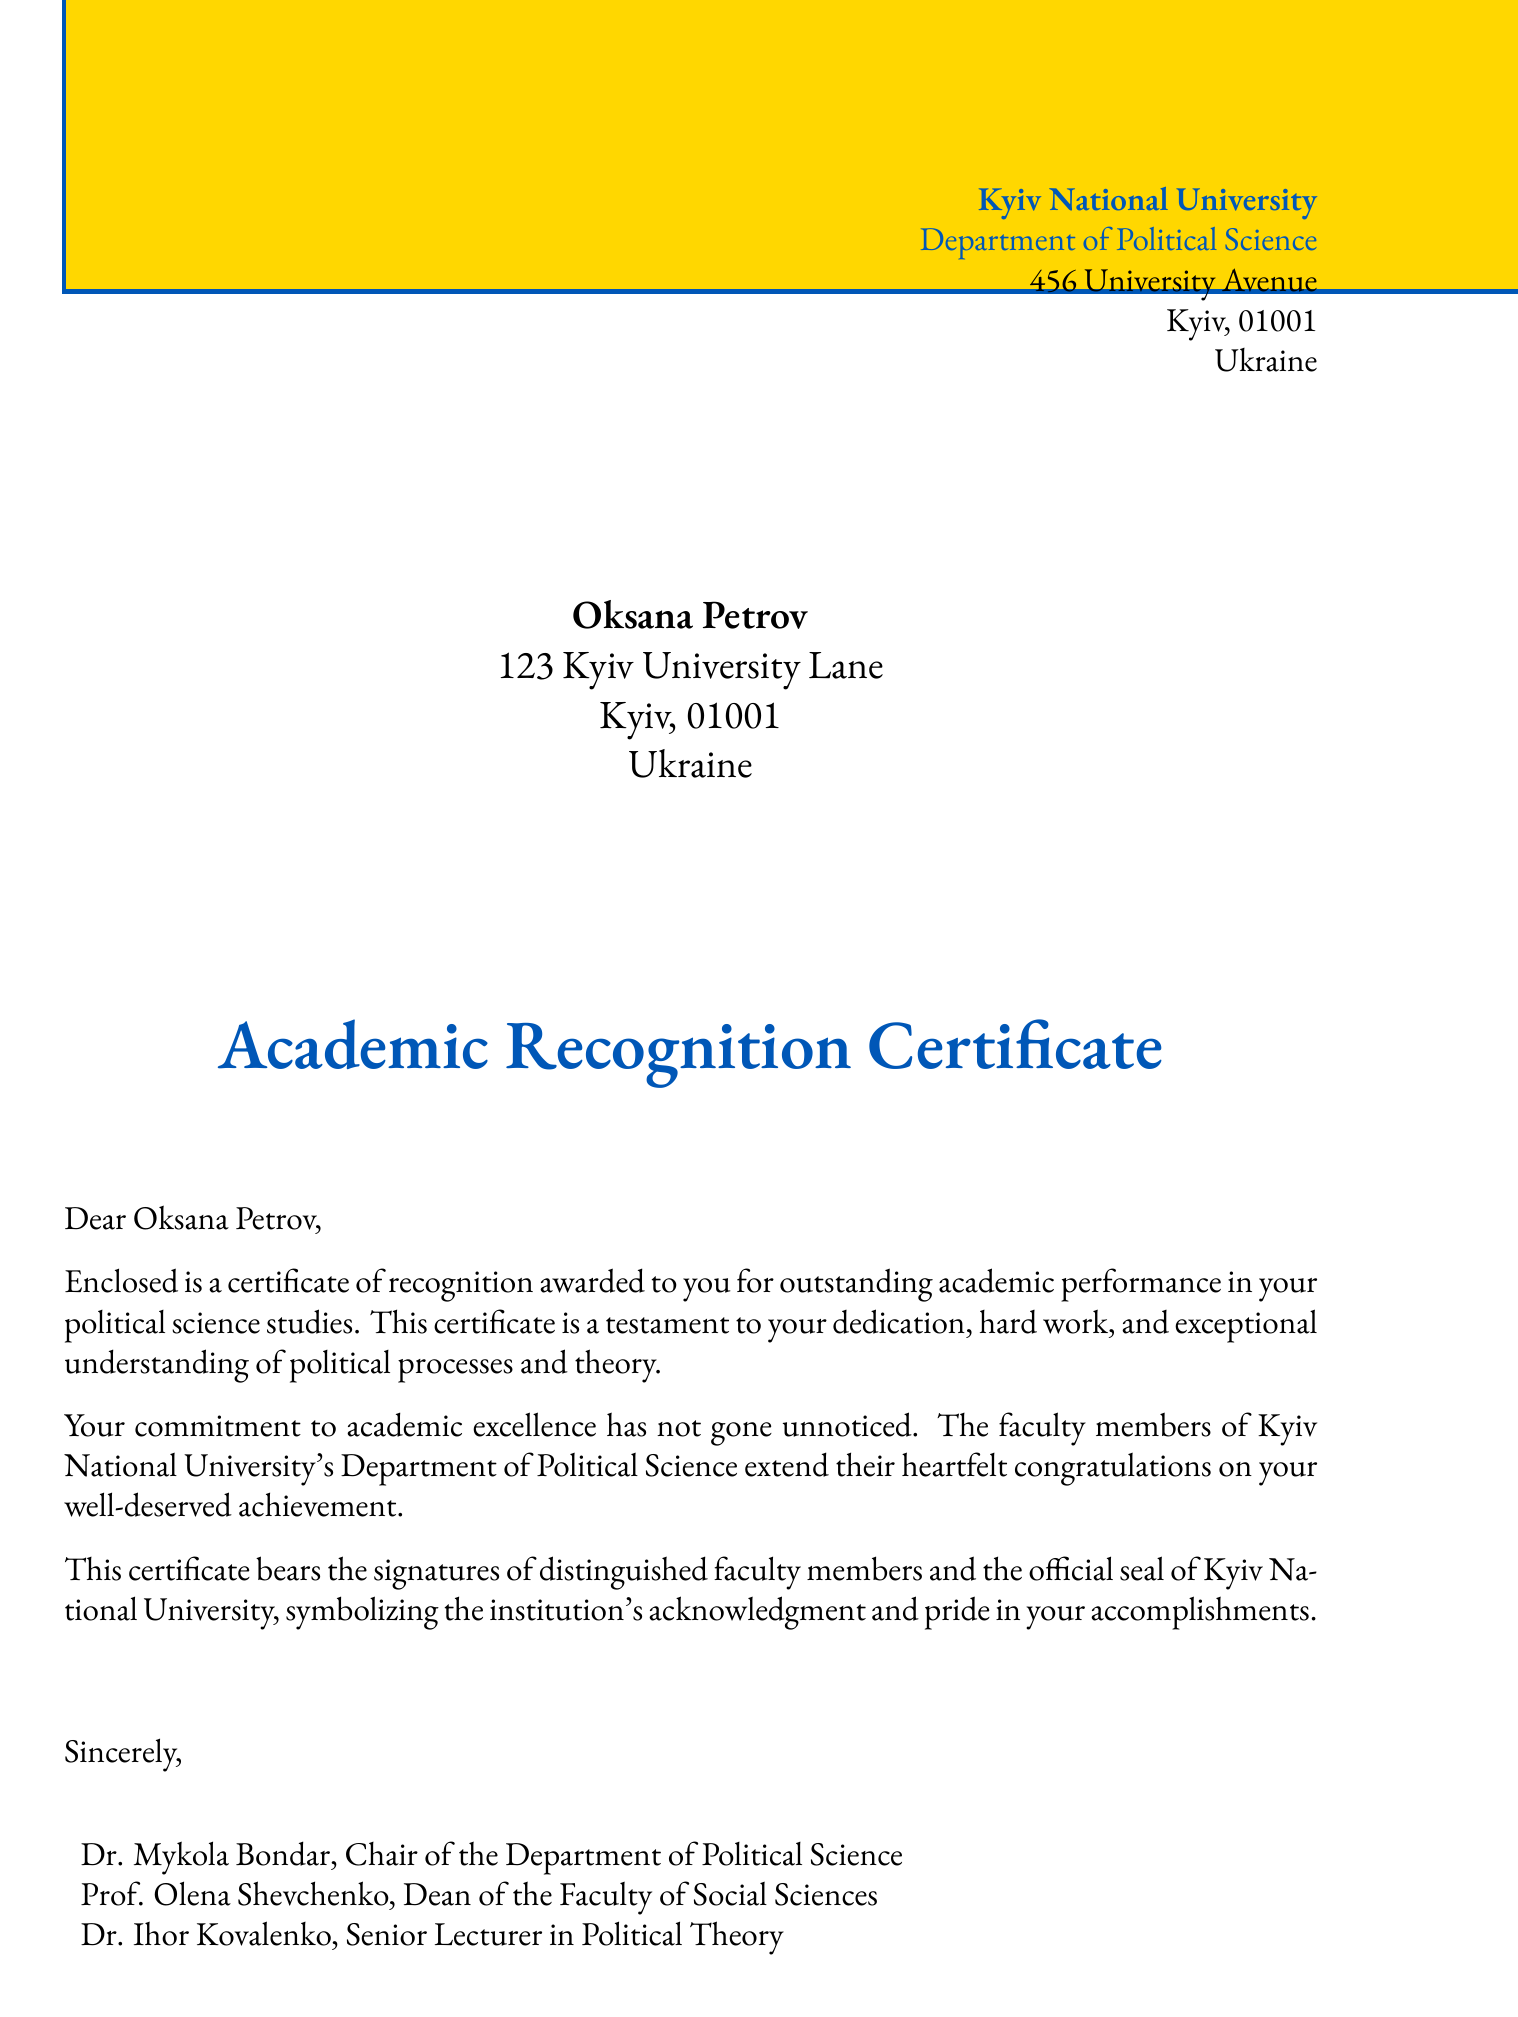what is the name of the student recognized? The document specifies the name of the student as Oksana Petrov, who is the recipient of the certificate.
Answer: Oksana Petrov who issued the certificate? The institution that issued the certificate is Kyiv National University, as indicated at the top of the document.
Answer: Kyiv National University what is the main purpose of this document? The primary purpose of the document is to award a certificate of recognition for outstanding academic performance.
Answer: recognition for outstanding academic performance which department is associated with the certificate? The department associated with this certificate is the Department of Political Science at Kyiv National University.
Answer: Department of Political Science who are the signatories on the certificate? The certificate is signed by Dr. Mykola Bondar, Prof. Olena Shevchenko, and Dr. Ihor Kovalenko.
Answer: Dr. Mykola Bondar, Prof. Olena Shevchenko, Dr. Ihor Kovalenko what color is used for the official seal? The official seal uses the color ukraineblue for its outline and text.
Answer: ukraineblue what does the certificate symbolize? The certificate symbolizes the institution's acknowledgment and pride in the student's accomplishments.
Answer: acknowledgment and pride how many faculty members signed the certificate? There are three faculty members who signed the certificate, as listed in the document.
Answer: three 